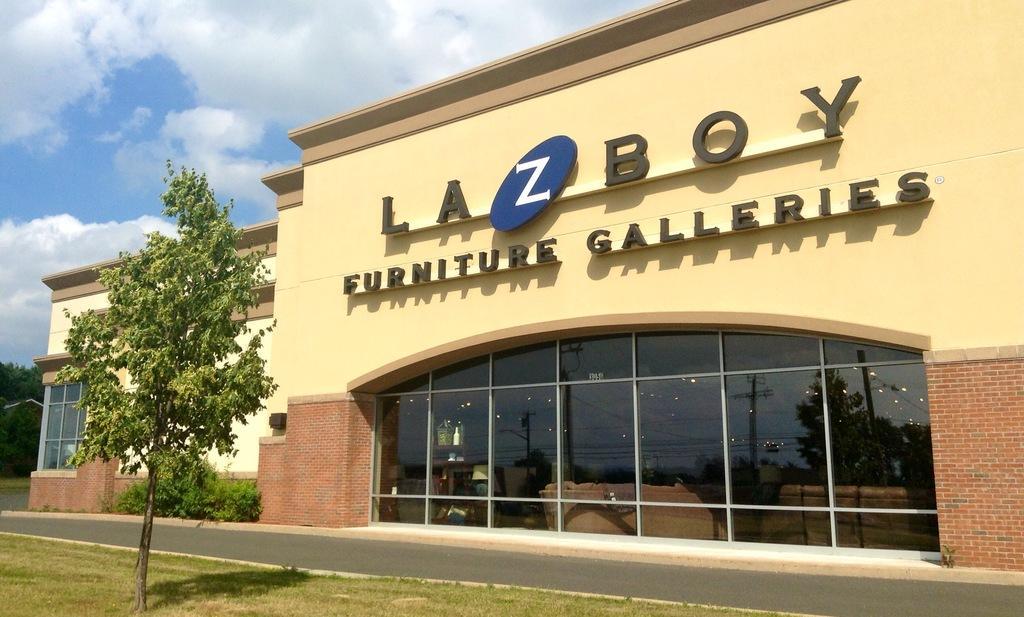How would you summarize this image in a sentence or two? In this image there is the sky towards the top of the image, there are clouds in the sky, there is a building towards the right of the image, there is text on the building, there are glass windows, there is a wall, there is road, there is a tree towards the left of the image, there are plants, there is grass towards the bottom of the image. 